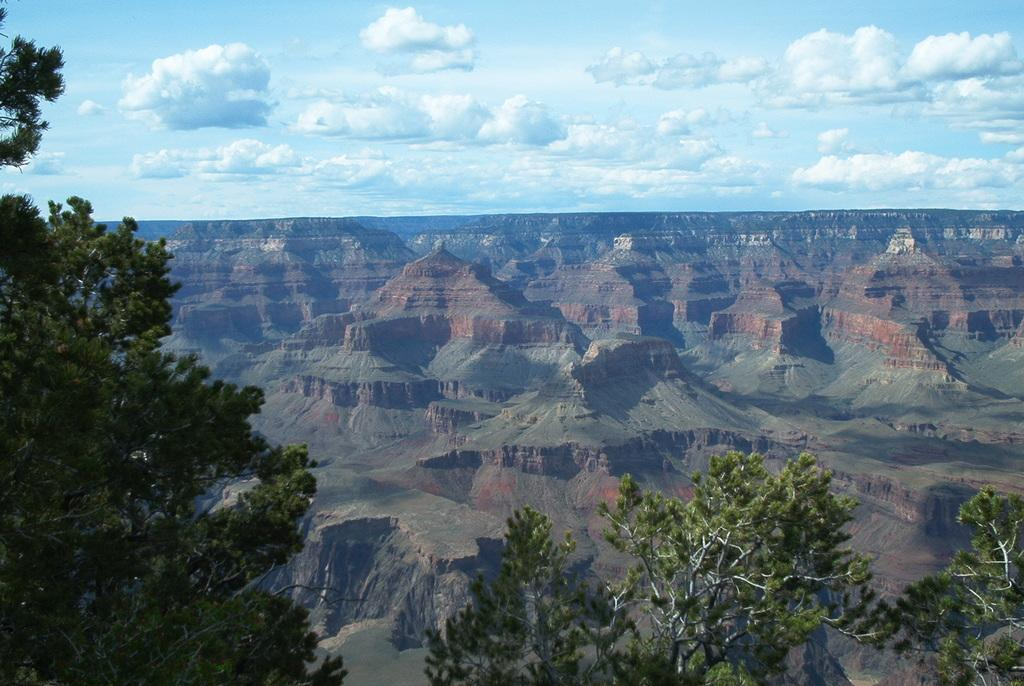What type of vegetation is on the left side of the image? There are trees on the left side of the image. What type of vegetation is on the right side of the image? There are trees on the right side of the image. What is the background of the image? The background of the image features the Grand Canyon National Park. What is visible in the sky in the image? The sky is visible in the image, and clouds are present. What type of leather is being kicked in the image? There is no leather or kicking activity present in the image. How many eggs are visible in the image? There are no eggs present in the image. 